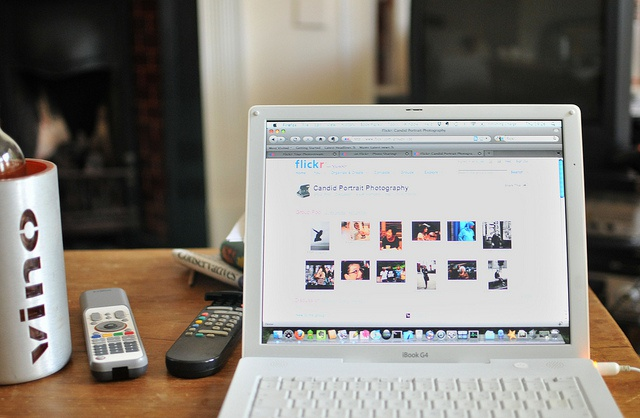Describe the objects in this image and their specific colors. I can see laptop in black, lightgray, darkgray, and lightblue tones, cup in black, lightgray, darkgray, maroon, and gray tones, remote in black, darkgray, lightgray, and gray tones, remote in black, gray, and darkgray tones, and bottle in black, maroon, gray, and darkgray tones in this image. 